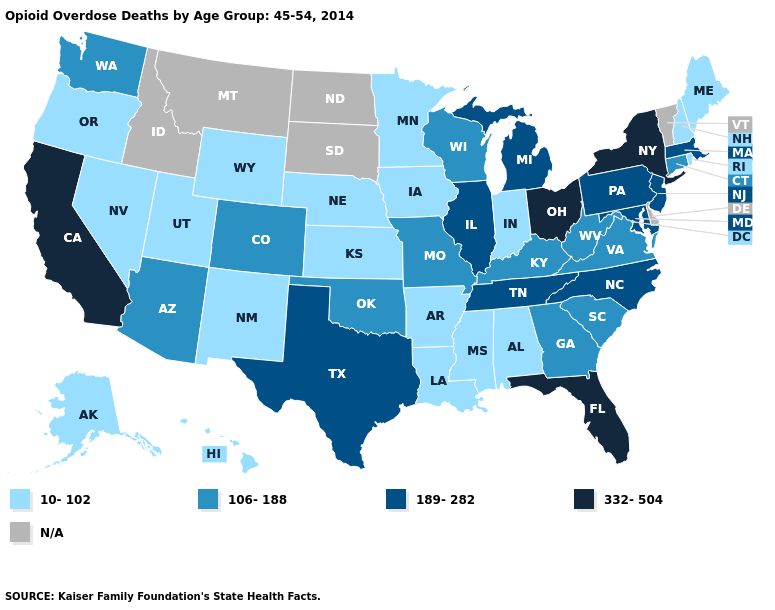Does Tennessee have the lowest value in the USA?
Keep it brief. No. Among the states that border South Carolina , which have the lowest value?
Write a very short answer. Georgia. Name the states that have a value in the range N/A?
Quick response, please. Delaware, Idaho, Montana, North Dakota, South Dakota, Vermont. Name the states that have a value in the range 189-282?
Short answer required. Illinois, Maryland, Massachusetts, Michigan, New Jersey, North Carolina, Pennsylvania, Tennessee, Texas. Which states have the lowest value in the USA?
Keep it brief. Alabama, Alaska, Arkansas, Hawaii, Indiana, Iowa, Kansas, Louisiana, Maine, Minnesota, Mississippi, Nebraska, Nevada, New Hampshire, New Mexico, Oregon, Rhode Island, Utah, Wyoming. Name the states that have a value in the range 332-504?
Keep it brief. California, Florida, New York, Ohio. What is the value of South Carolina?
Write a very short answer. 106-188. Name the states that have a value in the range 332-504?
Quick response, please. California, Florida, New York, Ohio. Does the first symbol in the legend represent the smallest category?
Concise answer only. Yes. Does Iowa have the lowest value in the USA?
Keep it brief. Yes. What is the value of West Virginia?
Short answer required. 106-188. What is the lowest value in the Northeast?
Write a very short answer. 10-102. Among the states that border Oregon , which have the highest value?
Give a very brief answer. California. Does Oklahoma have the lowest value in the USA?
Answer briefly. No. Name the states that have a value in the range 106-188?
Quick response, please. Arizona, Colorado, Connecticut, Georgia, Kentucky, Missouri, Oklahoma, South Carolina, Virginia, Washington, West Virginia, Wisconsin. 